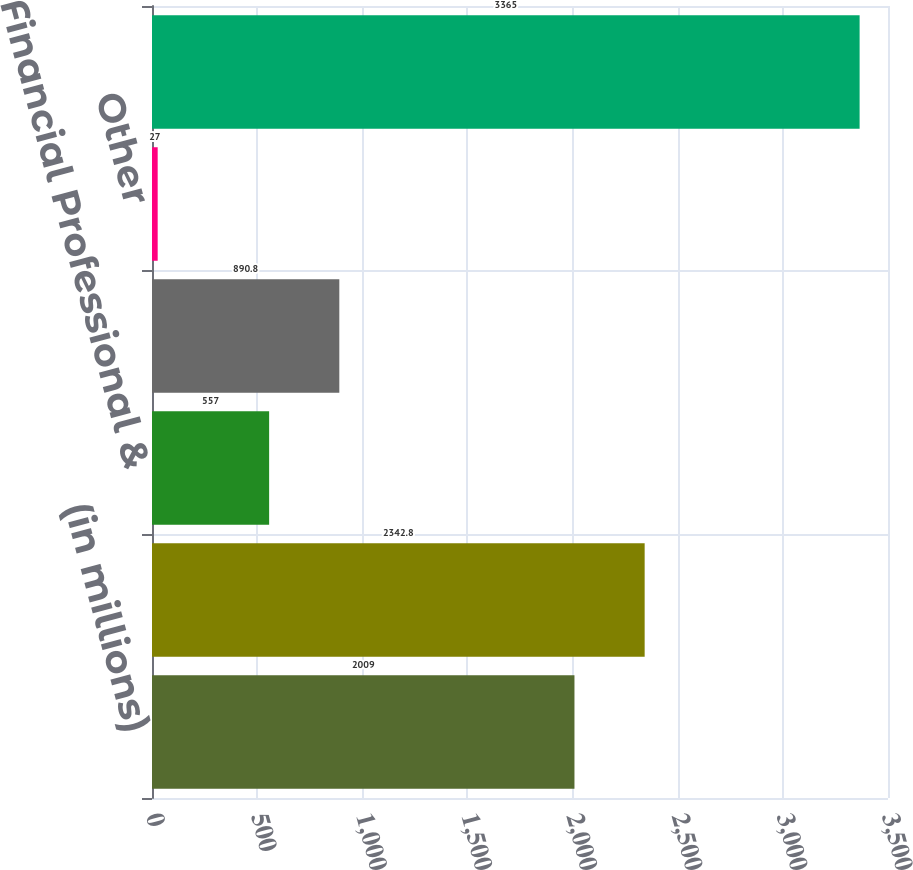<chart> <loc_0><loc_0><loc_500><loc_500><bar_chart><fcel>(in millions)<fcel>Business Insurance<fcel>Financial Professional &<fcel>Personal Insurance<fcel>Other<fcel>Total<nl><fcel>2009<fcel>2342.8<fcel>557<fcel>890.8<fcel>27<fcel>3365<nl></chart> 